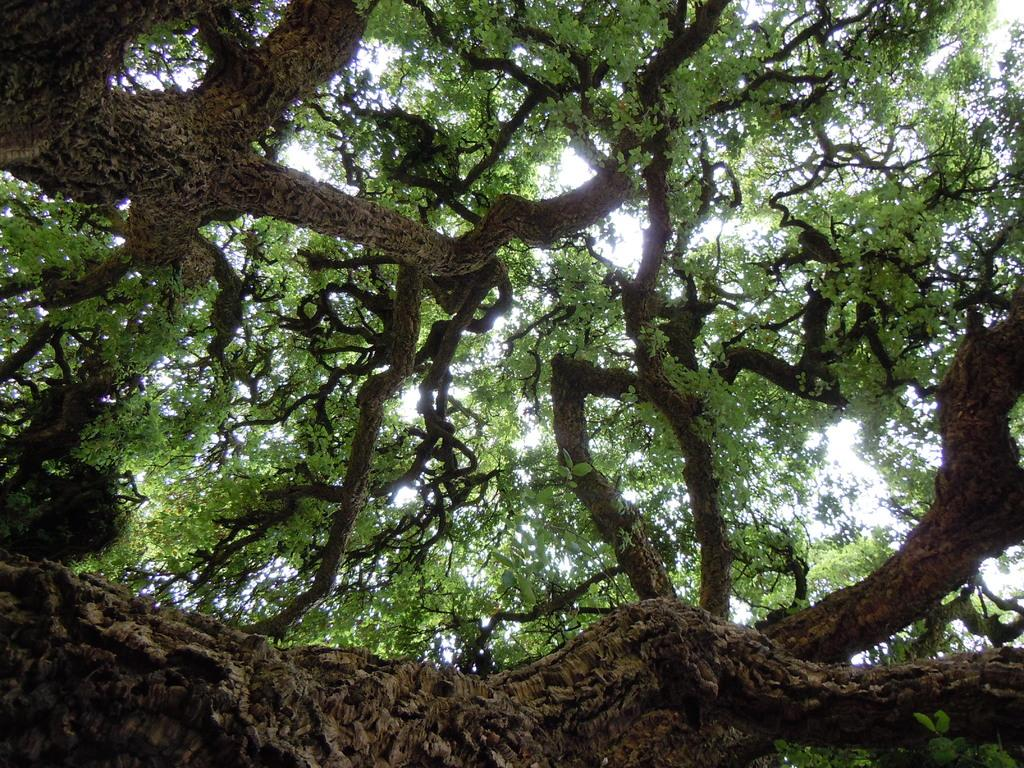What type of vegetation can be seen in the image? There are trees in the image. What letters are written on the ball in the image? There is no ball present in the image, and therefore no letters can be found on it. What is the cause of death depicted in the image? There is no depiction of death in the image; it only features trees. 